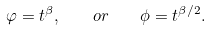<formula> <loc_0><loc_0><loc_500><loc_500>\varphi = t ^ { \beta } , \quad o r \quad \phi = t ^ { \beta / 2 } .</formula> 